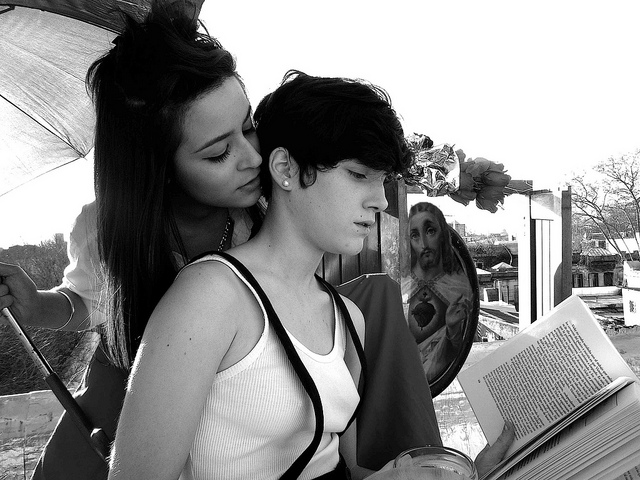<image>What kind of flowers are near the woman's head? I am not sure what kind of flowers are near the woman's head. It can be roses or daisies. What kind of flowers are near the woman's head? I am not sure what kind of flowers are near the woman's head. It can be seen roses or daisies. 